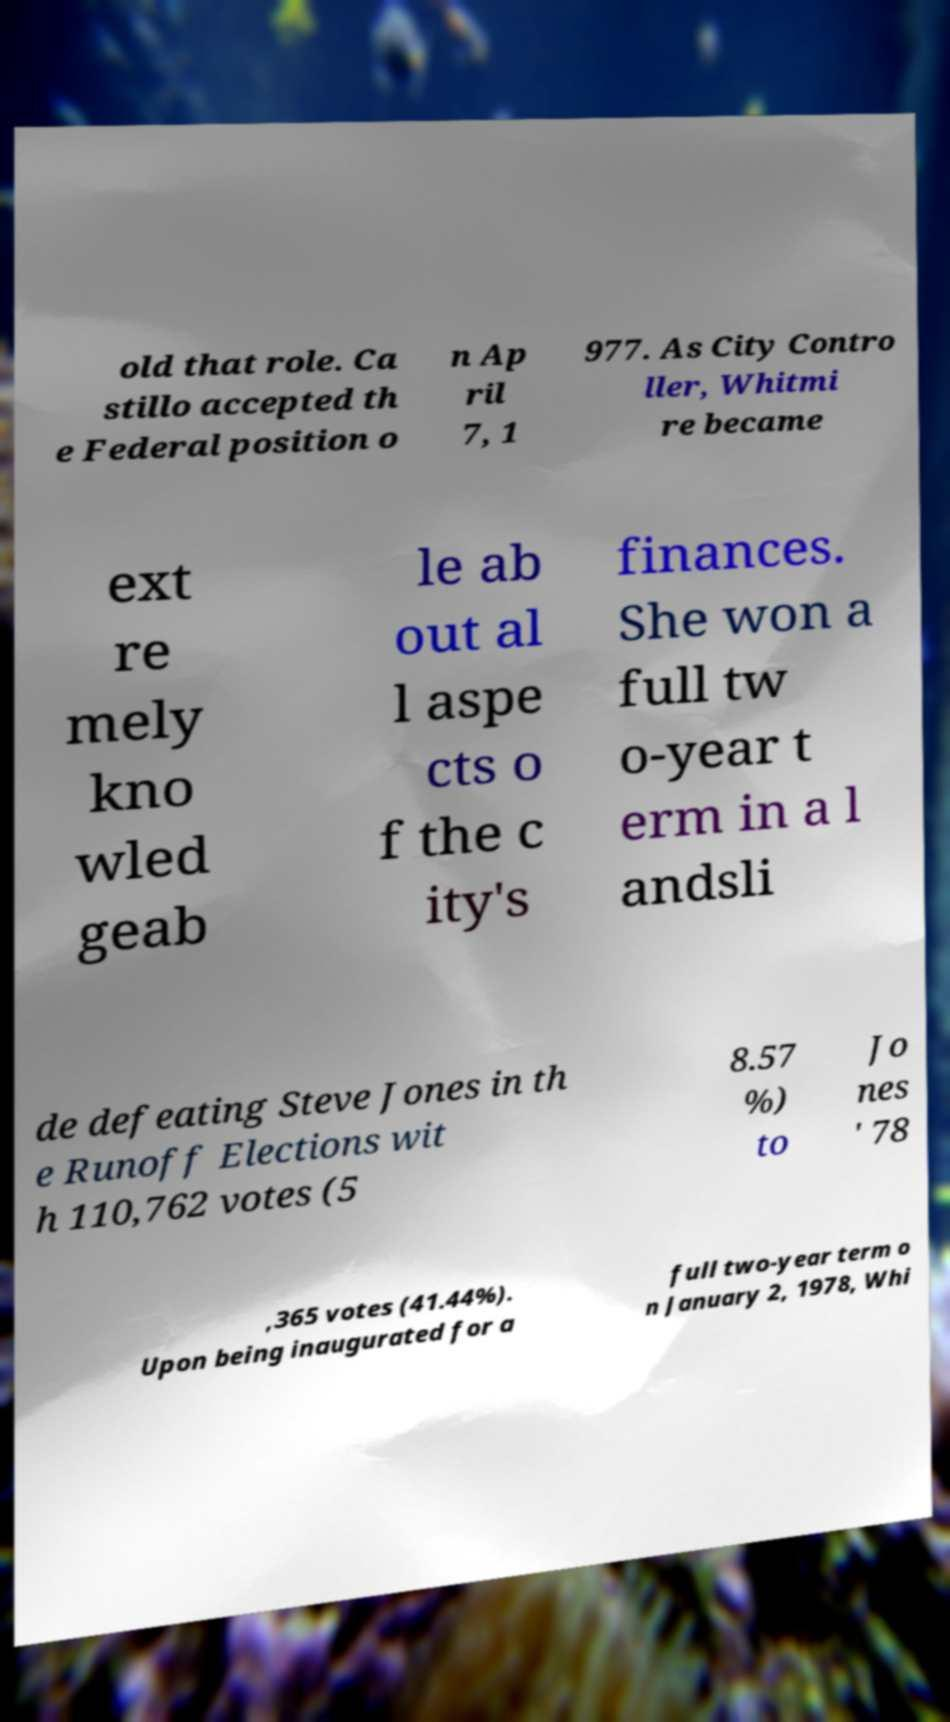I need the written content from this picture converted into text. Can you do that? old that role. Ca stillo accepted th e Federal position o n Ap ril 7, 1 977. As City Contro ller, Whitmi re became ext re mely kno wled geab le ab out al l aspe cts o f the c ity's finances. She won a full tw o-year t erm in a l andsli de defeating Steve Jones in th e Runoff Elections wit h 110,762 votes (5 8.57 %) to Jo nes ' 78 ,365 votes (41.44%). Upon being inaugurated for a full two-year term o n January 2, 1978, Whi 